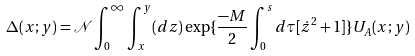Convert formula to latex. <formula><loc_0><loc_0><loc_500><loc_500>\Delta ( x ; y ) = { \mathcal { N } } \int _ { 0 } ^ { \infty } \int _ { x } ^ { y } ( d z ) \exp \{ \frac { - M } { 2 } \int _ { 0 } ^ { s } d \tau [ \dot { z } ^ { 2 } + 1 ] \} U _ { A } ( x ; y )</formula> 